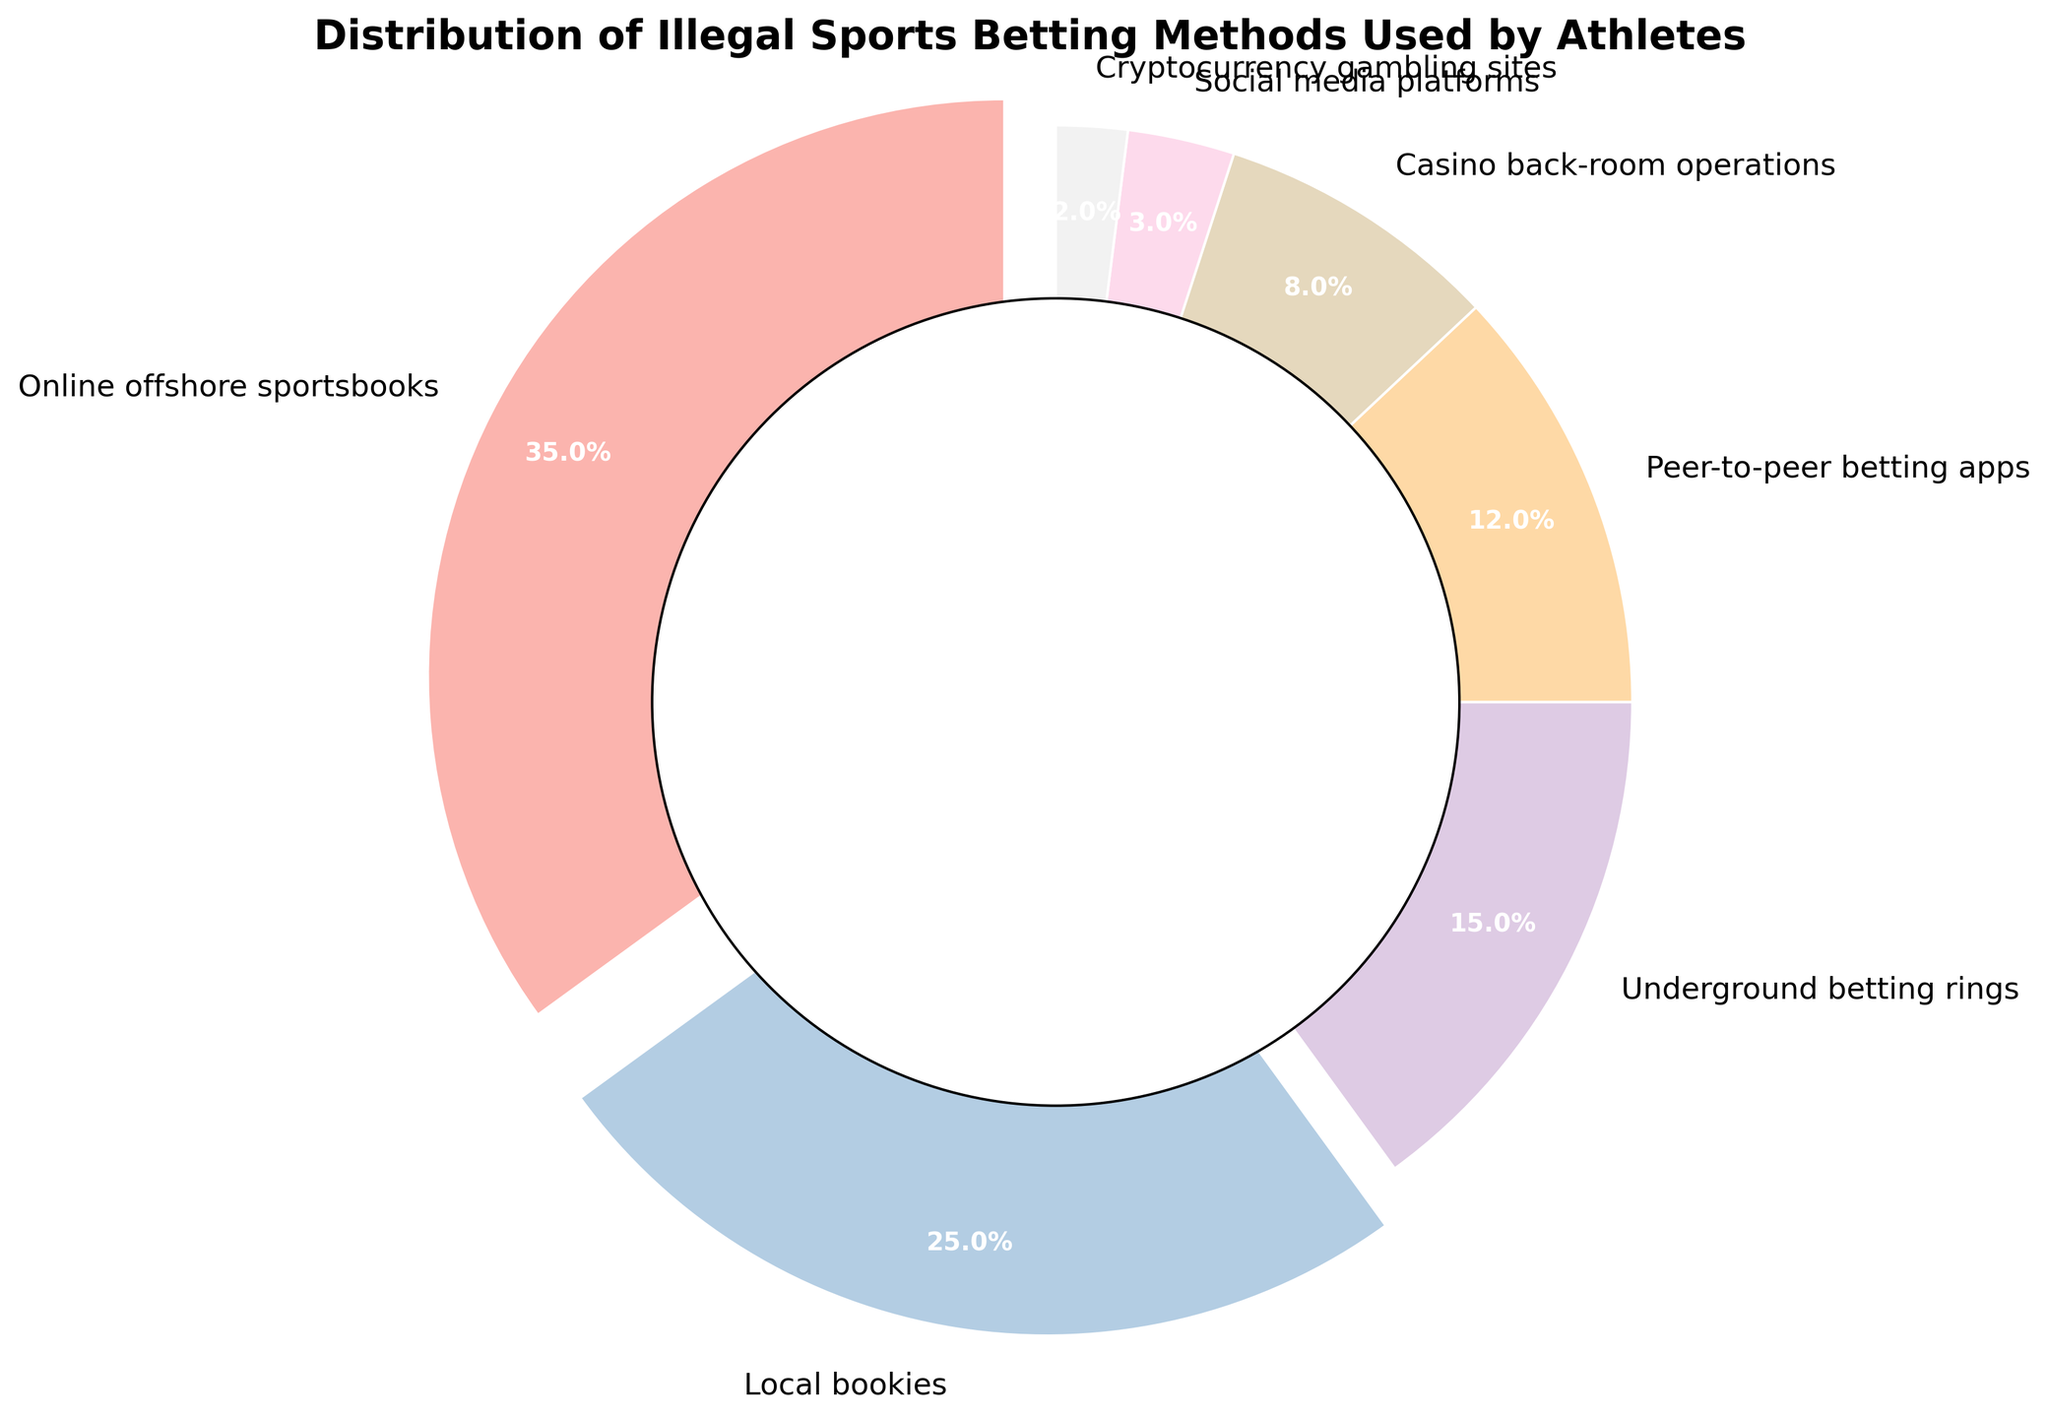What's the most common illegal sports betting method used by athletes? The pie chart shows that the largest segment is "Online offshore sportsbooks" with 35%.
Answer: Online offshore sportsbooks Which method is least used for illegal sports betting by athletes? The pie chart indicates that the smallest segment is "Cryptocurrency gambling sites" with 2%.
Answer: Cryptocurrency gambling sites How much more popular are online offshore sportsbooks than peer-to-peer betting apps? Online offshore sportsbooks have 35%, and peer-to-peer betting apps have 12%. The difference is 35% - 12% = 23%.
Answer: 23% If underground betting rings and local bookies are combined, what percentage do they constitute? Underground betting rings have 15%, and local bookies have 25%. Together they make up 15% + 25% = 40%.
Answer: 40% Which third most common method is used for illegal sports betting by athletes? The pie chart shows that the third largest segment is "Underground betting rings" with 15%.
Answer: Underground betting rings Are casino back-room operations or social media platforms more common for illegal sports betting among athletes? Casino back-room operations have 8%, while social media platforms have 3%. Since 8% > 3%, casino back-room operations are more common.
Answer: Casino back-room operations What percentage of illegal sports betting methods fall below 10% individually? The methods with percentages below 10% are casino back-room operations (8%), social media platforms (3%), and cryptocurrency gambling sites (2%). So, 3 methods fall below 10%.
Answer: 3 methods What is the combined percentage of all betting methods that individually fall under 5%? Social media platforms (3%) and cryptocurrency gambling sites (2%) both fall under 5%. Combined, they constitute 3% + 2% = 5%.
Answer: 5% How much more is the percentage of local bookies compared to casino back-room operations? Local bookies have 25%, and casino back-room operations have 8%. The difference is 25% - 8% = 17%.
Answer: 17% List the betting methods in descending order of their usage by percentage. Referring to the pie chart: 1. Online offshore sportsbooks (35%) 2. Local bookies (25%) 3. Underground betting rings (15%) 4. Peer-to-peer betting apps (12%) 5. Casino back-room operations (8%) 6. Social media platforms (3%) 7. Cryptocurrency gambling sites (2%)
Answer: Online offshore sportsbooks, Local bookies, Underground betting rings, Peer-to-peer betting apps, Casino back-room operations, Social media platforms, Cryptocurrency gambling sites 